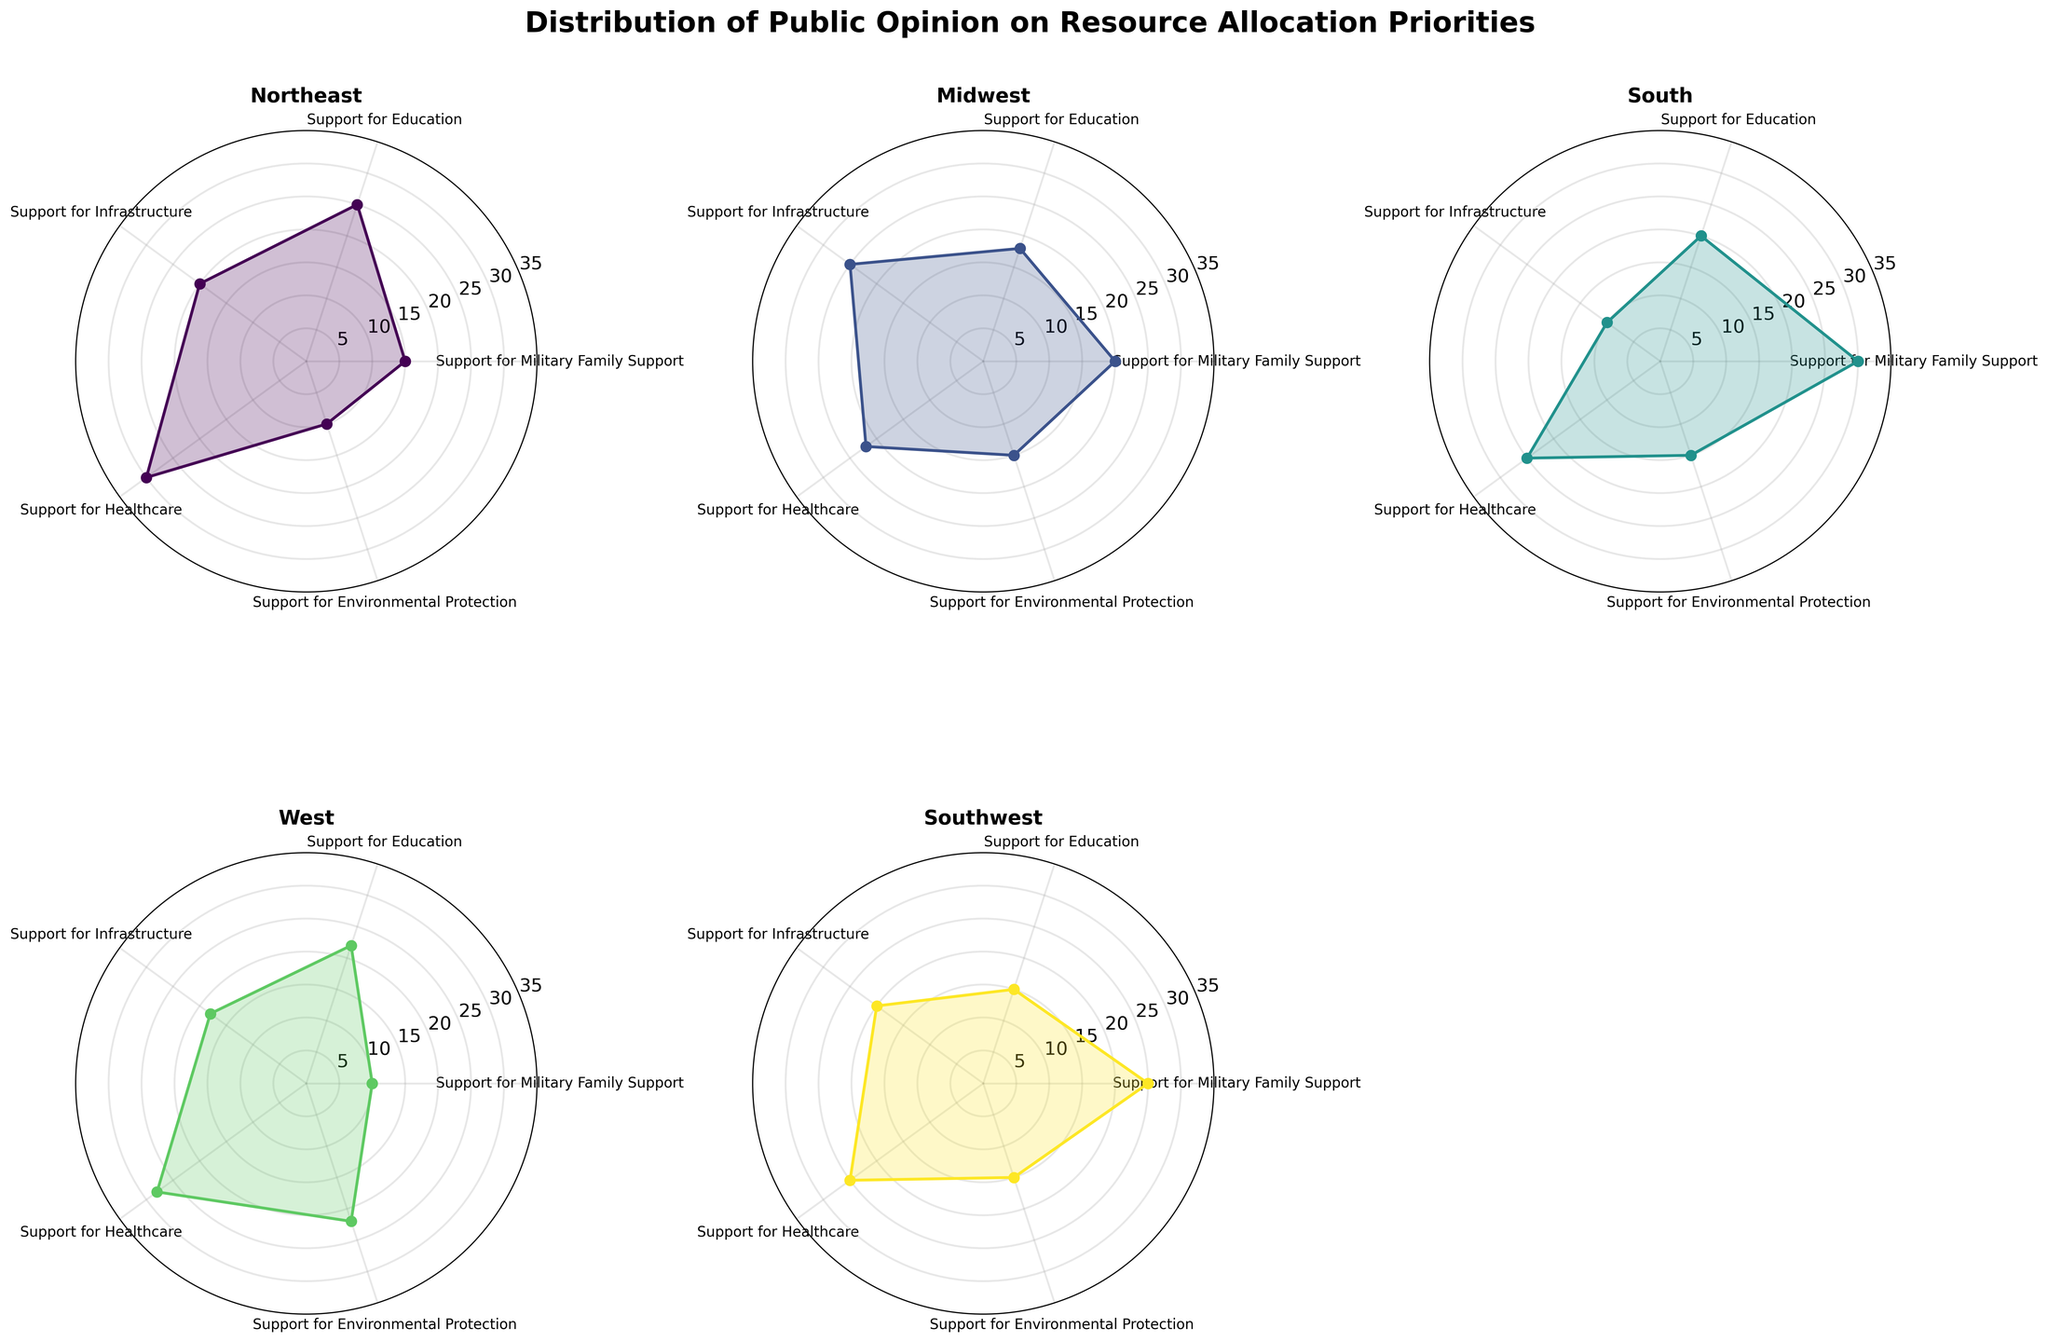Which region has the highest support for Military Family Support? The region with the highest support for Military Family Support can be determined by looking at the angle corresponding to Military Family Support and finding the region that has the largest value.
Answer: South Which region shows the least support for Environmental Protection? To find the region with the least support for Environmental Protection, check the angle corresponding to Environmental Protection and identify the region with the smallest value.
Answer: Northeast Compare the level of support for Healthcare between the Northeast and the West. Which region shows higher support? To compare Healthcare support, look at the angle corresponding to Healthcare for both the Northeast and West regions. The region with the larger value is the one with higher support.
Answer: Northeast What is the average support for Education across all regions? Calculate the average support for Education by summing the values for Education from all regions and dividing by the number of regions: (25 + 18 + 20 + 22 + 15) / 5.
Answer: 20 Which region has the most balanced support distribution across different categories? The most balanced support distribution can be identified by finding the region whose values for all categories are closest to each other, indicating minimal deviation among categories. This involves visually assessing the uniformity of the height of nodes in the plot.
Answer: Midwest 